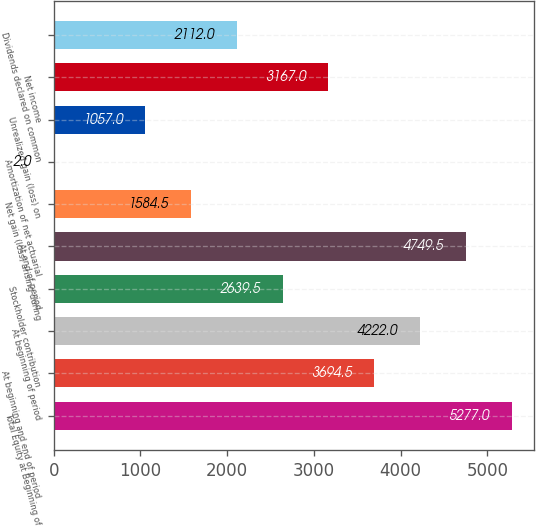Convert chart to OTSL. <chart><loc_0><loc_0><loc_500><loc_500><bar_chart><fcel>Total Equity at Beginning of<fcel>At beginning and end of period<fcel>At beginning of period<fcel>Stockholder contribution<fcel>At end of period<fcel>Net gain (loss) arising during<fcel>Amortization of net actuarial<fcel>Unrealized gain (loss) on<fcel>Net income<fcel>Dividends declared on common<nl><fcel>5277<fcel>3694.5<fcel>4222<fcel>2639.5<fcel>4749.5<fcel>1584.5<fcel>2<fcel>1057<fcel>3167<fcel>2112<nl></chart> 